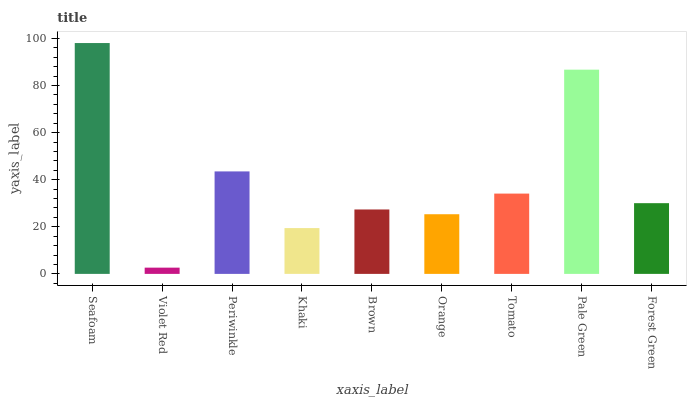Is Violet Red the minimum?
Answer yes or no. Yes. Is Seafoam the maximum?
Answer yes or no. Yes. Is Periwinkle the minimum?
Answer yes or no. No. Is Periwinkle the maximum?
Answer yes or no. No. Is Periwinkle greater than Violet Red?
Answer yes or no. Yes. Is Violet Red less than Periwinkle?
Answer yes or no. Yes. Is Violet Red greater than Periwinkle?
Answer yes or no. No. Is Periwinkle less than Violet Red?
Answer yes or no. No. Is Forest Green the high median?
Answer yes or no. Yes. Is Forest Green the low median?
Answer yes or no. Yes. Is Pale Green the high median?
Answer yes or no. No. Is Violet Red the low median?
Answer yes or no. No. 